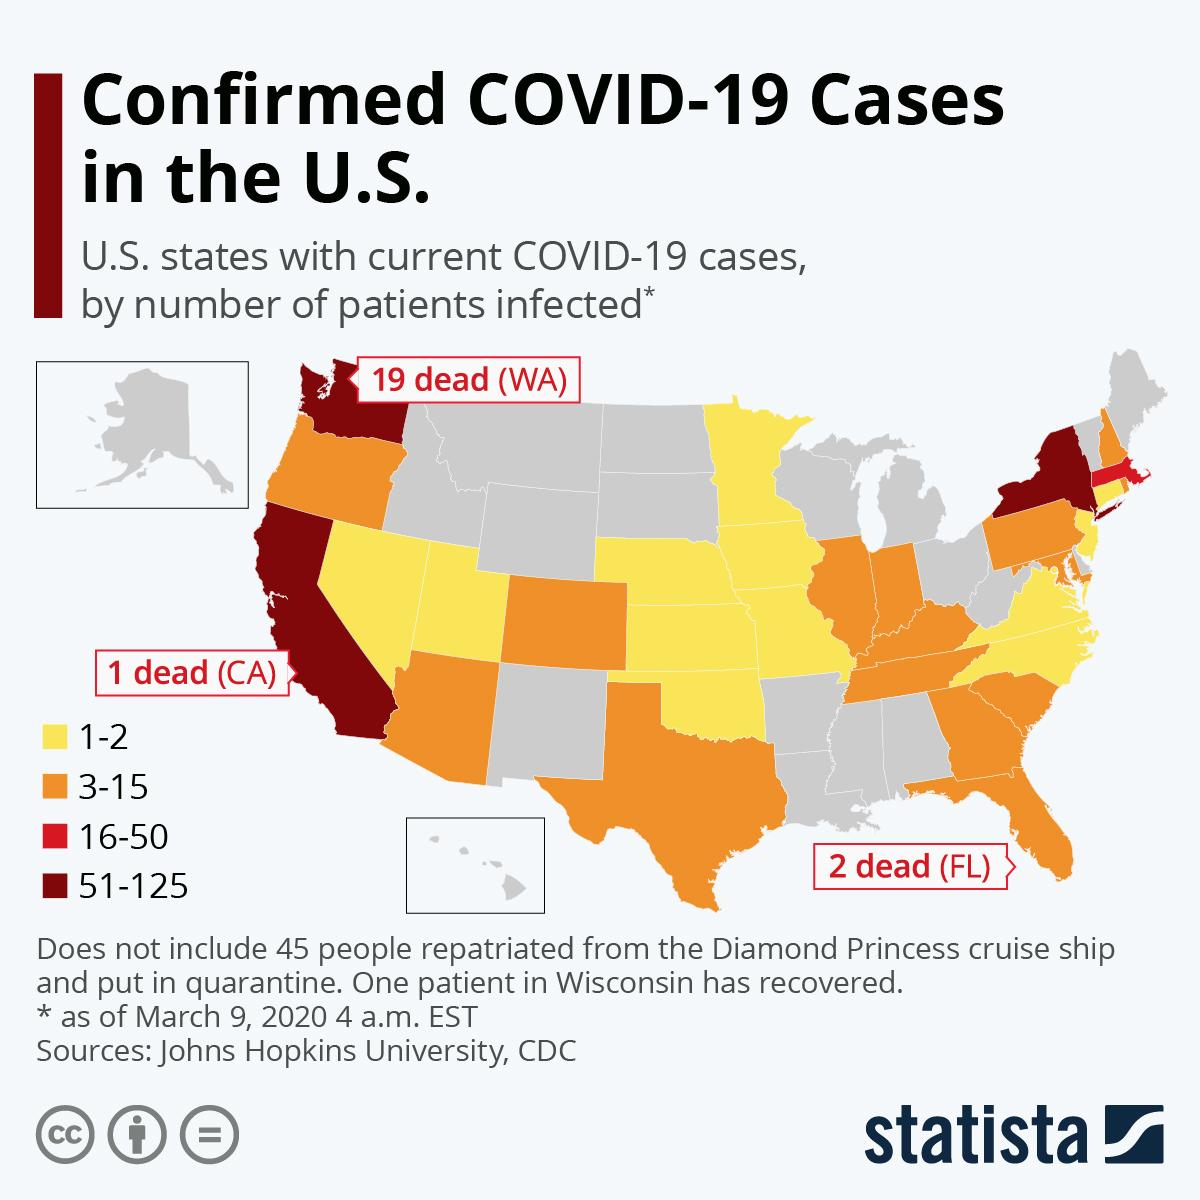Mention a couple of crucial points in this snapshot. The state with the highest number of deaths is Washington. According to the information provided, a total of 3 to 15 patients in states colored orange have been infected. The states with 1-2 patients are represented in yellow in the given table. Out of the states with a high number of COVID-19 patients, approximately 3 have 51 to 125 infected individuals. 